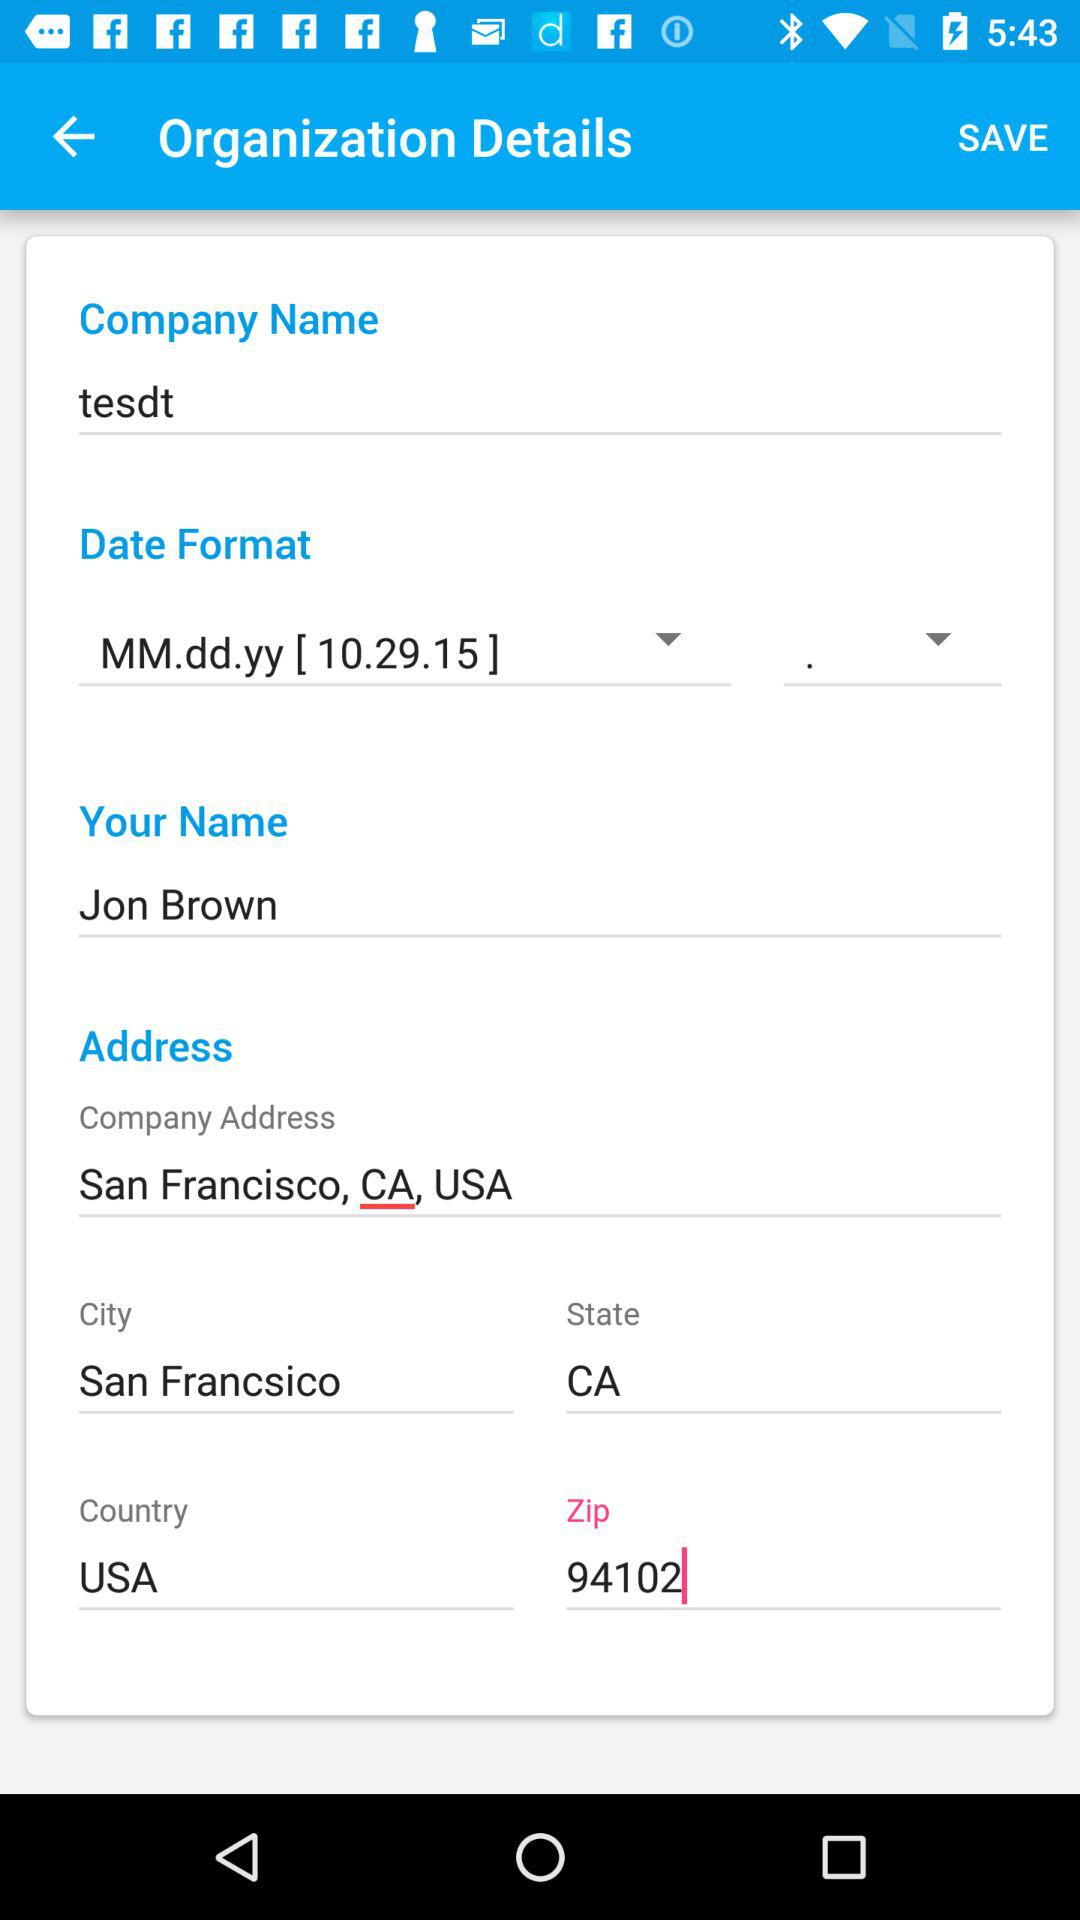What is the selected country? The selected country is the USA. 